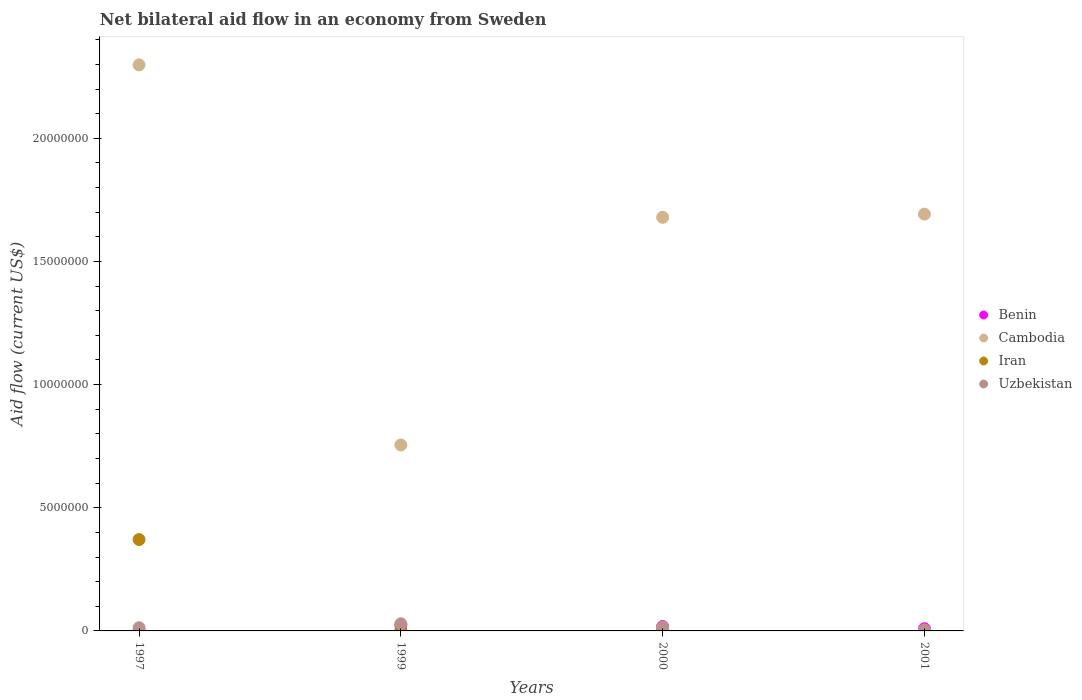How many different coloured dotlines are there?
Provide a short and direct response. 4. What is the net bilateral aid flow in Iran in 2000?
Offer a very short reply. 6.00e+04. Across all years, what is the maximum net bilateral aid flow in Iran?
Give a very brief answer. 3.71e+06. In which year was the net bilateral aid flow in Cambodia maximum?
Provide a succinct answer. 1997. What is the total net bilateral aid flow in Benin in the graph?
Your answer should be very brief. 5.10e+05. What is the difference between the net bilateral aid flow in Iran in 1997 and that in 2000?
Make the answer very short. 3.65e+06. What is the average net bilateral aid flow in Benin per year?
Give a very brief answer. 1.28e+05. In the year 2000, what is the difference between the net bilateral aid flow in Iran and net bilateral aid flow in Benin?
Make the answer very short. -1.20e+05. What is the ratio of the net bilateral aid flow in Uzbekistan in 1997 to that in 2000?
Offer a terse response. 0.81. Is the difference between the net bilateral aid flow in Iran in 1997 and 2001 greater than the difference between the net bilateral aid flow in Benin in 1997 and 2001?
Your answer should be compact. Yes. What is the difference between the highest and the second highest net bilateral aid flow in Iran?
Ensure brevity in your answer.  3.65e+06. What is the difference between the highest and the lowest net bilateral aid flow in Iran?
Provide a short and direct response. 3.68e+06. Is it the case that in every year, the sum of the net bilateral aid flow in Benin and net bilateral aid flow in Cambodia  is greater than the net bilateral aid flow in Iran?
Your answer should be compact. Yes. How many years are there in the graph?
Offer a very short reply. 4. What is the difference between two consecutive major ticks on the Y-axis?
Your response must be concise. 5.00e+06. Does the graph contain any zero values?
Your response must be concise. No. What is the title of the graph?
Provide a succinct answer. Net bilateral aid flow in an economy from Sweden. What is the label or title of the Y-axis?
Offer a very short reply. Aid flow (current US$). What is the Aid flow (current US$) in Cambodia in 1997?
Give a very brief answer. 2.30e+07. What is the Aid flow (current US$) in Iran in 1997?
Give a very brief answer. 3.71e+06. What is the Aid flow (current US$) in Cambodia in 1999?
Offer a very short reply. 7.55e+06. What is the Aid flow (current US$) of Iran in 1999?
Offer a terse response. 3.00e+04. What is the Aid flow (current US$) of Benin in 2000?
Your answer should be very brief. 1.80e+05. What is the Aid flow (current US$) in Cambodia in 2000?
Provide a succinct answer. 1.68e+07. What is the Aid flow (current US$) in Uzbekistan in 2000?
Keep it short and to the point. 1.60e+05. What is the Aid flow (current US$) of Cambodia in 2001?
Give a very brief answer. 1.69e+07. What is the Aid flow (current US$) in Iran in 2001?
Your answer should be very brief. 3.00e+04. What is the Aid flow (current US$) in Uzbekistan in 2001?
Give a very brief answer. 4.00e+04. Across all years, what is the maximum Aid flow (current US$) of Benin?
Your answer should be compact. 2.30e+05. Across all years, what is the maximum Aid flow (current US$) of Cambodia?
Your answer should be very brief. 2.30e+07. Across all years, what is the maximum Aid flow (current US$) in Iran?
Give a very brief answer. 3.71e+06. Across all years, what is the minimum Aid flow (current US$) in Cambodia?
Provide a succinct answer. 7.55e+06. Across all years, what is the minimum Aid flow (current US$) in Uzbekistan?
Give a very brief answer. 4.00e+04. What is the total Aid flow (current US$) in Benin in the graph?
Offer a terse response. 5.10e+05. What is the total Aid flow (current US$) in Cambodia in the graph?
Your response must be concise. 6.42e+07. What is the total Aid flow (current US$) in Iran in the graph?
Keep it short and to the point. 3.83e+06. What is the total Aid flow (current US$) of Uzbekistan in the graph?
Keep it short and to the point. 6.20e+05. What is the difference between the Aid flow (current US$) of Cambodia in 1997 and that in 1999?
Offer a very short reply. 1.54e+07. What is the difference between the Aid flow (current US$) of Iran in 1997 and that in 1999?
Offer a terse response. 3.68e+06. What is the difference between the Aid flow (current US$) of Benin in 1997 and that in 2000?
Your answer should be compact. -1.70e+05. What is the difference between the Aid flow (current US$) in Cambodia in 1997 and that in 2000?
Give a very brief answer. 6.19e+06. What is the difference between the Aid flow (current US$) in Iran in 1997 and that in 2000?
Provide a short and direct response. 3.65e+06. What is the difference between the Aid flow (current US$) in Uzbekistan in 1997 and that in 2000?
Ensure brevity in your answer.  -3.00e+04. What is the difference between the Aid flow (current US$) in Cambodia in 1997 and that in 2001?
Offer a very short reply. 6.06e+06. What is the difference between the Aid flow (current US$) in Iran in 1997 and that in 2001?
Give a very brief answer. 3.68e+06. What is the difference between the Aid flow (current US$) of Uzbekistan in 1997 and that in 2001?
Offer a terse response. 9.00e+04. What is the difference between the Aid flow (current US$) of Cambodia in 1999 and that in 2000?
Provide a short and direct response. -9.24e+06. What is the difference between the Aid flow (current US$) of Uzbekistan in 1999 and that in 2000?
Ensure brevity in your answer.  1.30e+05. What is the difference between the Aid flow (current US$) of Benin in 1999 and that in 2001?
Provide a succinct answer. 1.40e+05. What is the difference between the Aid flow (current US$) of Cambodia in 1999 and that in 2001?
Your answer should be compact. -9.37e+06. What is the difference between the Aid flow (current US$) of Iran in 1999 and that in 2001?
Offer a very short reply. 0. What is the difference between the Aid flow (current US$) in Uzbekistan in 1999 and that in 2001?
Offer a very short reply. 2.50e+05. What is the difference between the Aid flow (current US$) in Cambodia in 2000 and that in 2001?
Your response must be concise. -1.30e+05. What is the difference between the Aid flow (current US$) of Iran in 2000 and that in 2001?
Your answer should be very brief. 3.00e+04. What is the difference between the Aid flow (current US$) in Uzbekistan in 2000 and that in 2001?
Your response must be concise. 1.20e+05. What is the difference between the Aid flow (current US$) of Benin in 1997 and the Aid flow (current US$) of Cambodia in 1999?
Offer a very short reply. -7.54e+06. What is the difference between the Aid flow (current US$) of Benin in 1997 and the Aid flow (current US$) of Iran in 1999?
Provide a short and direct response. -2.00e+04. What is the difference between the Aid flow (current US$) in Benin in 1997 and the Aid flow (current US$) in Uzbekistan in 1999?
Your response must be concise. -2.80e+05. What is the difference between the Aid flow (current US$) in Cambodia in 1997 and the Aid flow (current US$) in Iran in 1999?
Provide a succinct answer. 2.30e+07. What is the difference between the Aid flow (current US$) of Cambodia in 1997 and the Aid flow (current US$) of Uzbekistan in 1999?
Give a very brief answer. 2.27e+07. What is the difference between the Aid flow (current US$) in Iran in 1997 and the Aid flow (current US$) in Uzbekistan in 1999?
Your response must be concise. 3.42e+06. What is the difference between the Aid flow (current US$) in Benin in 1997 and the Aid flow (current US$) in Cambodia in 2000?
Offer a terse response. -1.68e+07. What is the difference between the Aid flow (current US$) of Benin in 1997 and the Aid flow (current US$) of Iran in 2000?
Keep it short and to the point. -5.00e+04. What is the difference between the Aid flow (current US$) of Benin in 1997 and the Aid flow (current US$) of Uzbekistan in 2000?
Offer a terse response. -1.50e+05. What is the difference between the Aid flow (current US$) in Cambodia in 1997 and the Aid flow (current US$) in Iran in 2000?
Your answer should be compact. 2.29e+07. What is the difference between the Aid flow (current US$) in Cambodia in 1997 and the Aid flow (current US$) in Uzbekistan in 2000?
Give a very brief answer. 2.28e+07. What is the difference between the Aid flow (current US$) of Iran in 1997 and the Aid flow (current US$) of Uzbekistan in 2000?
Your response must be concise. 3.55e+06. What is the difference between the Aid flow (current US$) in Benin in 1997 and the Aid flow (current US$) in Cambodia in 2001?
Offer a very short reply. -1.69e+07. What is the difference between the Aid flow (current US$) in Benin in 1997 and the Aid flow (current US$) in Iran in 2001?
Provide a succinct answer. -2.00e+04. What is the difference between the Aid flow (current US$) of Benin in 1997 and the Aid flow (current US$) of Uzbekistan in 2001?
Offer a very short reply. -3.00e+04. What is the difference between the Aid flow (current US$) of Cambodia in 1997 and the Aid flow (current US$) of Iran in 2001?
Make the answer very short. 2.30e+07. What is the difference between the Aid flow (current US$) in Cambodia in 1997 and the Aid flow (current US$) in Uzbekistan in 2001?
Your response must be concise. 2.29e+07. What is the difference between the Aid flow (current US$) in Iran in 1997 and the Aid flow (current US$) in Uzbekistan in 2001?
Your response must be concise. 3.67e+06. What is the difference between the Aid flow (current US$) in Benin in 1999 and the Aid flow (current US$) in Cambodia in 2000?
Make the answer very short. -1.66e+07. What is the difference between the Aid flow (current US$) in Benin in 1999 and the Aid flow (current US$) in Iran in 2000?
Your response must be concise. 1.70e+05. What is the difference between the Aid flow (current US$) of Benin in 1999 and the Aid flow (current US$) of Uzbekistan in 2000?
Keep it short and to the point. 7.00e+04. What is the difference between the Aid flow (current US$) of Cambodia in 1999 and the Aid flow (current US$) of Iran in 2000?
Your answer should be very brief. 7.49e+06. What is the difference between the Aid flow (current US$) in Cambodia in 1999 and the Aid flow (current US$) in Uzbekistan in 2000?
Keep it short and to the point. 7.39e+06. What is the difference between the Aid flow (current US$) of Benin in 1999 and the Aid flow (current US$) of Cambodia in 2001?
Offer a very short reply. -1.67e+07. What is the difference between the Aid flow (current US$) in Benin in 1999 and the Aid flow (current US$) in Iran in 2001?
Provide a short and direct response. 2.00e+05. What is the difference between the Aid flow (current US$) of Cambodia in 1999 and the Aid flow (current US$) of Iran in 2001?
Ensure brevity in your answer.  7.52e+06. What is the difference between the Aid flow (current US$) in Cambodia in 1999 and the Aid flow (current US$) in Uzbekistan in 2001?
Offer a very short reply. 7.51e+06. What is the difference between the Aid flow (current US$) in Iran in 1999 and the Aid flow (current US$) in Uzbekistan in 2001?
Provide a short and direct response. -10000. What is the difference between the Aid flow (current US$) of Benin in 2000 and the Aid flow (current US$) of Cambodia in 2001?
Keep it short and to the point. -1.67e+07. What is the difference between the Aid flow (current US$) in Benin in 2000 and the Aid flow (current US$) in Iran in 2001?
Ensure brevity in your answer.  1.50e+05. What is the difference between the Aid flow (current US$) in Cambodia in 2000 and the Aid flow (current US$) in Iran in 2001?
Offer a very short reply. 1.68e+07. What is the difference between the Aid flow (current US$) of Cambodia in 2000 and the Aid flow (current US$) of Uzbekistan in 2001?
Your answer should be compact. 1.68e+07. What is the average Aid flow (current US$) of Benin per year?
Provide a short and direct response. 1.28e+05. What is the average Aid flow (current US$) in Cambodia per year?
Provide a succinct answer. 1.61e+07. What is the average Aid flow (current US$) of Iran per year?
Your answer should be compact. 9.58e+05. What is the average Aid flow (current US$) in Uzbekistan per year?
Provide a succinct answer. 1.55e+05. In the year 1997, what is the difference between the Aid flow (current US$) of Benin and Aid flow (current US$) of Cambodia?
Give a very brief answer. -2.30e+07. In the year 1997, what is the difference between the Aid flow (current US$) in Benin and Aid flow (current US$) in Iran?
Your answer should be compact. -3.70e+06. In the year 1997, what is the difference between the Aid flow (current US$) in Cambodia and Aid flow (current US$) in Iran?
Provide a short and direct response. 1.93e+07. In the year 1997, what is the difference between the Aid flow (current US$) of Cambodia and Aid flow (current US$) of Uzbekistan?
Provide a short and direct response. 2.28e+07. In the year 1997, what is the difference between the Aid flow (current US$) of Iran and Aid flow (current US$) of Uzbekistan?
Keep it short and to the point. 3.58e+06. In the year 1999, what is the difference between the Aid flow (current US$) of Benin and Aid flow (current US$) of Cambodia?
Give a very brief answer. -7.32e+06. In the year 1999, what is the difference between the Aid flow (current US$) of Benin and Aid flow (current US$) of Iran?
Give a very brief answer. 2.00e+05. In the year 1999, what is the difference between the Aid flow (current US$) in Benin and Aid flow (current US$) in Uzbekistan?
Give a very brief answer. -6.00e+04. In the year 1999, what is the difference between the Aid flow (current US$) in Cambodia and Aid flow (current US$) in Iran?
Keep it short and to the point. 7.52e+06. In the year 1999, what is the difference between the Aid flow (current US$) in Cambodia and Aid flow (current US$) in Uzbekistan?
Make the answer very short. 7.26e+06. In the year 2000, what is the difference between the Aid flow (current US$) of Benin and Aid flow (current US$) of Cambodia?
Your response must be concise. -1.66e+07. In the year 2000, what is the difference between the Aid flow (current US$) in Benin and Aid flow (current US$) in Iran?
Your answer should be very brief. 1.20e+05. In the year 2000, what is the difference between the Aid flow (current US$) in Benin and Aid flow (current US$) in Uzbekistan?
Offer a very short reply. 2.00e+04. In the year 2000, what is the difference between the Aid flow (current US$) of Cambodia and Aid flow (current US$) of Iran?
Make the answer very short. 1.67e+07. In the year 2000, what is the difference between the Aid flow (current US$) of Cambodia and Aid flow (current US$) of Uzbekistan?
Offer a very short reply. 1.66e+07. In the year 2001, what is the difference between the Aid flow (current US$) in Benin and Aid flow (current US$) in Cambodia?
Provide a short and direct response. -1.68e+07. In the year 2001, what is the difference between the Aid flow (current US$) of Cambodia and Aid flow (current US$) of Iran?
Give a very brief answer. 1.69e+07. In the year 2001, what is the difference between the Aid flow (current US$) of Cambodia and Aid flow (current US$) of Uzbekistan?
Your response must be concise. 1.69e+07. In the year 2001, what is the difference between the Aid flow (current US$) in Iran and Aid flow (current US$) in Uzbekistan?
Your response must be concise. -10000. What is the ratio of the Aid flow (current US$) in Benin in 1997 to that in 1999?
Your response must be concise. 0.04. What is the ratio of the Aid flow (current US$) of Cambodia in 1997 to that in 1999?
Give a very brief answer. 3.04. What is the ratio of the Aid flow (current US$) of Iran in 1997 to that in 1999?
Offer a terse response. 123.67. What is the ratio of the Aid flow (current US$) in Uzbekistan in 1997 to that in 1999?
Make the answer very short. 0.45. What is the ratio of the Aid flow (current US$) in Benin in 1997 to that in 2000?
Keep it short and to the point. 0.06. What is the ratio of the Aid flow (current US$) in Cambodia in 1997 to that in 2000?
Offer a very short reply. 1.37. What is the ratio of the Aid flow (current US$) of Iran in 1997 to that in 2000?
Offer a terse response. 61.83. What is the ratio of the Aid flow (current US$) in Uzbekistan in 1997 to that in 2000?
Your answer should be very brief. 0.81. What is the ratio of the Aid flow (current US$) of Cambodia in 1997 to that in 2001?
Provide a succinct answer. 1.36. What is the ratio of the Aid flow (current US$) in Iran in 1997 to that in 2001?
Your answer should be very brief. 123.67. What is the ratio of the Aid flow (current US$) in Uzbekistan in 1997 to that in 2001?
Keep it short and to the point. 3.25. What is the ratio of the Aid flow (current US$) in Benin in 1999 to that in 2000?
Provide a succinct answer. 1.28. What is the ratio of the Aid flow (current US$) in Cambodia in 1999 to that in 2000?
Offer a very short reply. 0.45. What is the ratio of the Aid flow (current US$) of Iran in 1999 to that in 2000?
Ensure brevity in your answer.  0.5. What is the ratio of the Aid flow (current US$) in Uzbekistan in 1999 to that in 2000?
Ensure brevity in your answer.  1.81. What is the ratio of the Aid flow (current US$) of Benin in 1999 to that in 2001?
Provide a succinct answer. 2.56. What is the ratio of the Aid flow (current US$) of Cambodia in 1999 to that in 2001?
Make the answer very short. 0.45. What is the ratio of the Aid flow (current US$) of Uzbekistan in 1999 to that in 2001?
Offer a very short reply. 7.25. What is the ratio of the Aid flow (current US$) of Benin in 2000 to that in 2001?
Your answer should be very brief. 2. What is the ratio of the Aid flow (current US$) of Cambodia in 2000 to that in 2001?
Your answer should be compact. 0.99. What is the ratio of the Aid flow (current US$) in Uzbekistan in 2000 to that in 2001?
Make the answer very short. 4. What is the difference between the highest and the second highest Aid flow (current US$) in Benin?
Your answer should be compact. 5.00e+04. What is the difference between the highest and the second highest Aid flow (current US$) of Cambodia?
Your answer should be compact. 6.06e+06. What is the difference between the highest and the second highest Aid flow (current US$) of Iran?
Your response must be concise. 3.65e+06. What is the difference between the highest and the lowest Aid flow (current US$) of Cambodia?
Make the answer very short. 1.54e+07. What is the difference between the highest and the lowest Aid flow (current US$) in Iran?
Provide a succinct answer. 3.68e+06. 